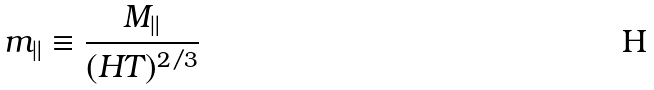Convert formula to latex. <formula><loc_0><loc_0><loc_500><loc_500>m _ { \| } \equiv \frac { M _ { \| } } { ( H T ) ^ { 2 / 3 } }</formula> 